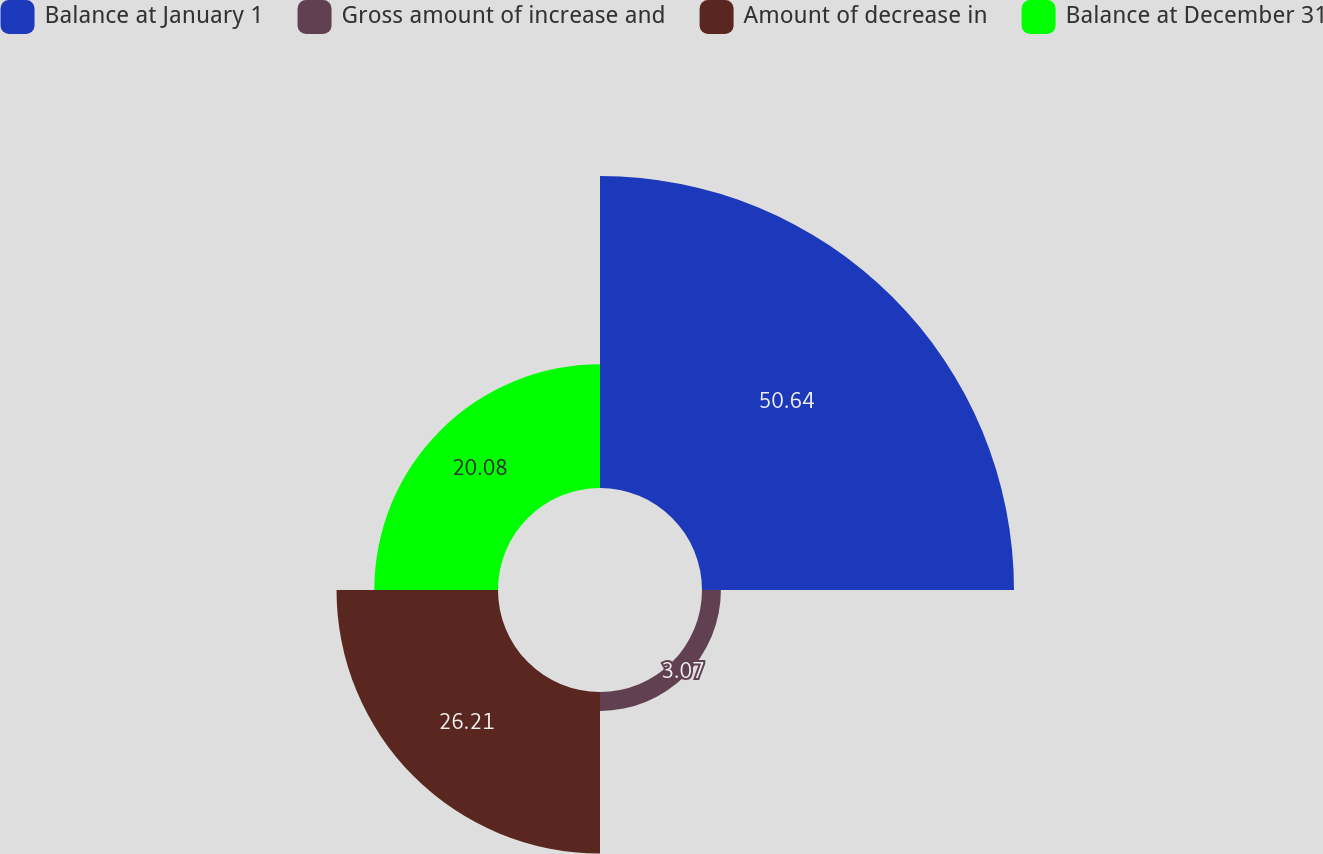Convert chart. <chart><loc_0><loc_0><loc_500><loc_500><pie_chart><fcel>Balance at January 1<fcel>Gross amount of increase and<fcel>Amount of decrease in<fcel>Balance at December 31<nl><fcel>50.64%<fcel>3.07%<fcel>26.21%<fcel>20.08%<nl></chart> 